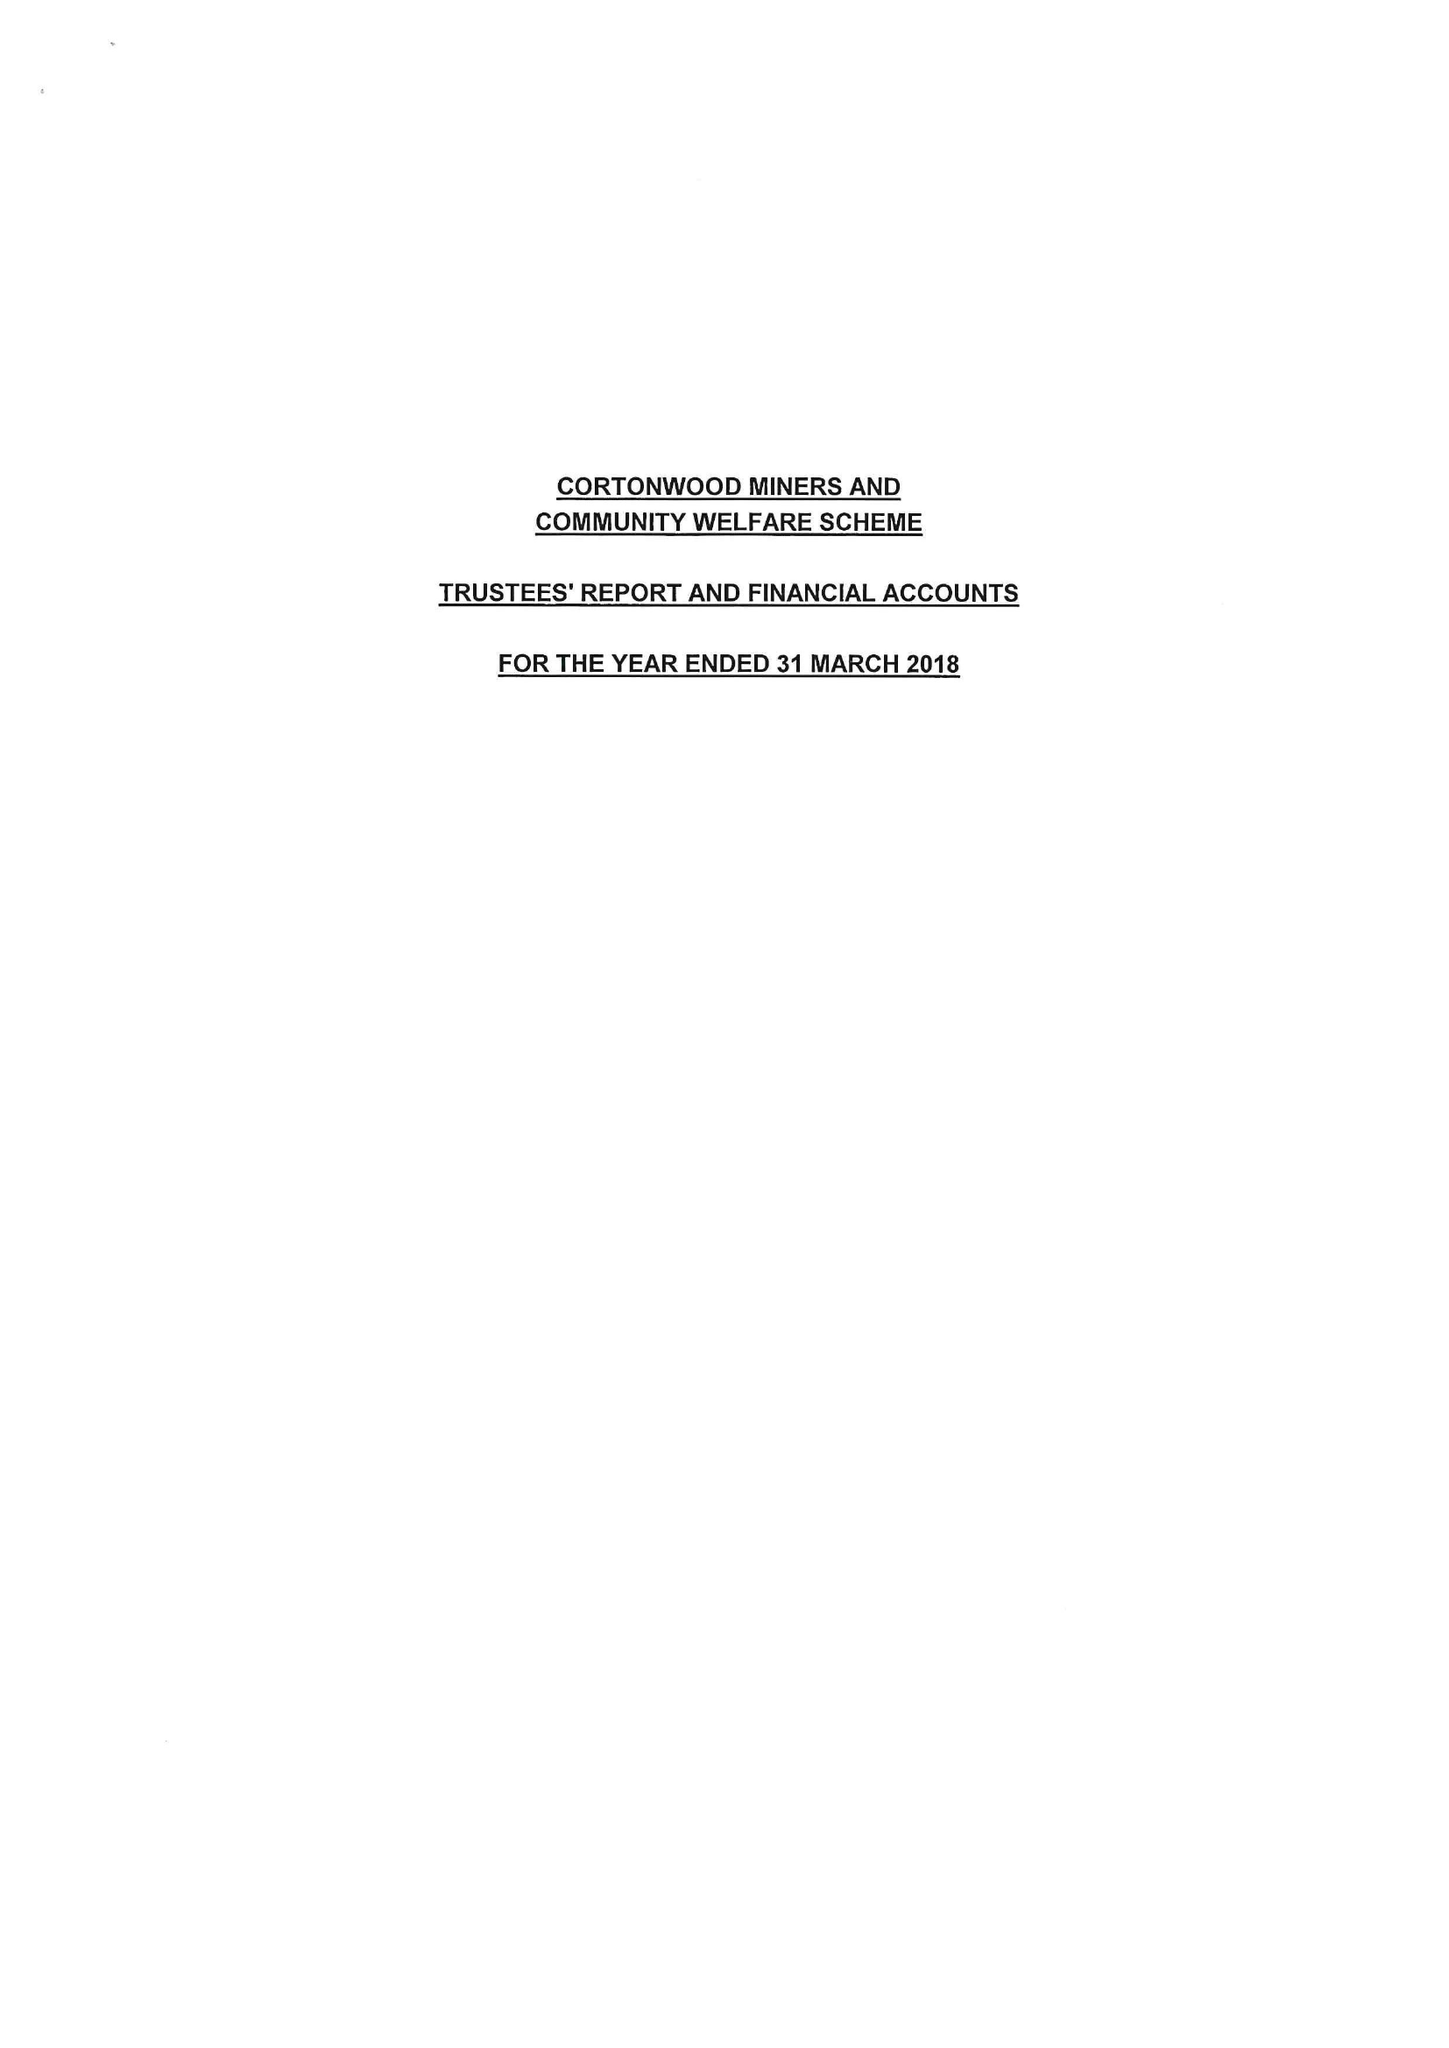What is the value for the charity_name?
Answer the question using a single word or phrase. Cortonwood Miners' Welfare Scheme 